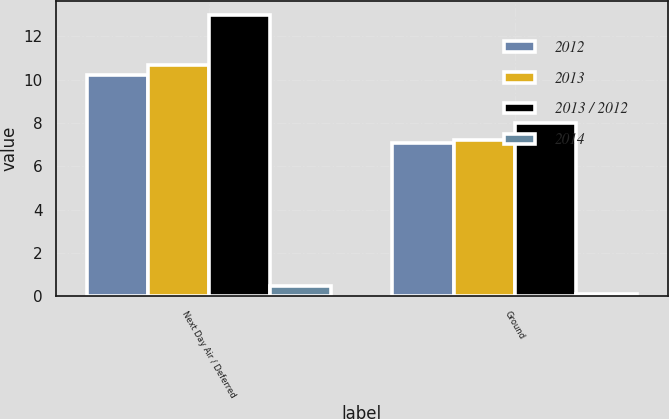<chart> <loc_0><loc_0><loc_500><loc_500><stacked_bar_chart><ecel><fcel>Next Day Air / Deferred<fcel>Ground<nl><fcel>2012<fcel>10.2<fcel>7.1<nl><fcel>2013<fcel>10.7<fcel>7.2<nl><fcel>2013 / 2012<fcel>13<fcel>8<nl><fcel>2014<fcel>0.5<fcel>0.1<nl></chart> 